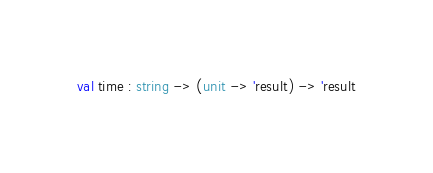<code> <loc_0><loc_0><loc_500><loc_500><_OCaml_>val time : string -> (unit -> 'result) -> 'result
</code> 